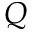<formula> <loc_0><loc_0><loc_500><loc_500>Q</formula> 